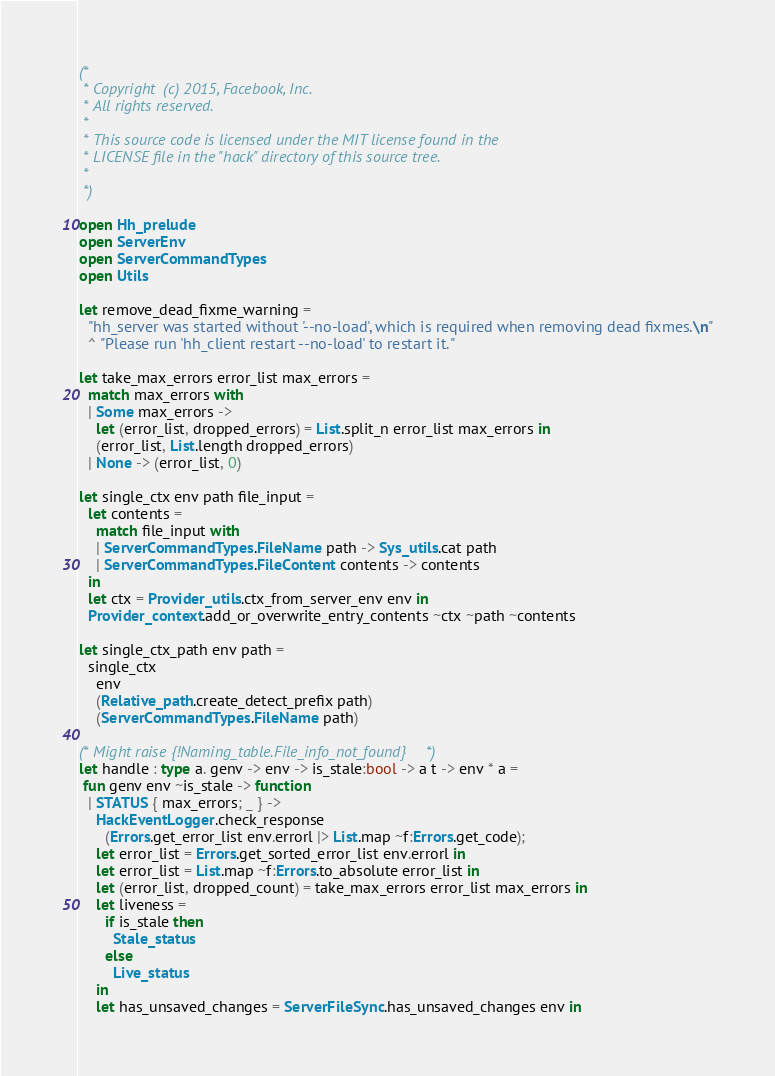<code> <loc_0><loc_0><loc_500><loc_500><_OCaml_>(*
 * Copyright (c) 2015, Facebook, Inc.
 * All rights reserved.
 *
 * This source code is licensed under the MIT license found in the
 * LICENSE file in the "hack" directory of this source tree.
 *
 *)

open Hh_prelude
open ServerEnv
open ServerCommandTypes
open Utils

let remove_dead_fixme_warning =
  "hh_server was started without '--no-load', which is required when removing dead fixmes.\n"
  ^ "Please run 'hh_client restart --no-load' to restart it."

let take_max_errors error_list max_errors =
  match max_errors with
  | Some max_errors ->
    let (error_list, dropped_errors) = List.split_n error_list max_errors in
    (error_list, List.length dropped_errors)
  | None -> (error_list, 0)

let single_ctx env path file_input =
  let contents =
    match file_input with
    | ServerCommandTypes.FileName path -> Sys_utils.cat path
    | ServerCommandTypes.FileContent contents -> contents
  in
  let ctx = Provider_utils.ctx_from_server_env env in
  Provider_context.add_or_overwrite_entry_contents ~ctx ~path ~contents

let single_ctx_path env path =
  single_ctx
    env
    (Relative_path.create_detect_prefix path)
    (ServerCommandTypes.FileName path)

(* Might raise {!Naming_table.File_info_not_found} *)
let handle : type a. genv -> env -> is_stale:bool -> a t -> env * a =
 fun genv env ~is_stale -> function
  | STATUS { max_errors; _ } ->
    HackEventLogger.check_response
      (Errors.get_error_list env.errorl |> List.map ~f:Errors.get_code);
    let error_list = Errors.get_sorted_error_list env.errorl in
    let error_list = List.map ~f:Errors.to_absolute error_list in
    let (error_list, dropped_count) = take_max_errors error_list max_errors in
    let liveness =
      if is_stale then
        Stale_status
      else
        Live_status
    in
    let has_unsaved_changes = ServerFileSync.has_unsaved_changes env in</code> 